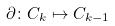<formula> <loc_0><loc_0><loc_500><loc_500>\partial \colon C _ { k } \mapsto C _ { k - 1 }</formula> 